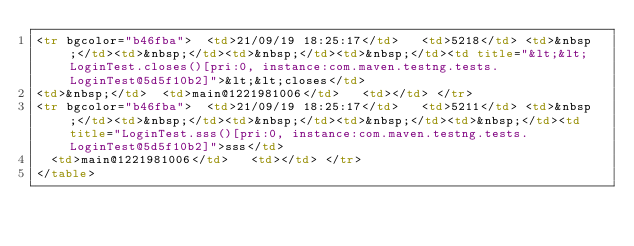Convert code to text. <code><loc_0><loc_0><loc_500><loc_500><_HTML_><tr bgcolor="b46fba">  <td>21/09/19 18:25:17</td>   <td>5218</td> <td>&nbsp;</td><td>&nbsp;</td><td>&nbsp;</td><td>&nbsp;</td><td title="&lt;&lt;LoginTest.closes()[pri:0, instance:com.maven.testng.tests.LoginTest@5d5f10b2]">&lt;&lt;closes</td> 
<td>&nbsp;</td>  <td>main@1221981006</td>   <td></td> </tr>
<tr bgcolor="b46fba">  <td>21/09/19 18:25:17</td>   <td>5211</td> <td>&nbsp;</td><td>&nbsp;</td><td>&nbsp;</td><td>&nbsp;</td><td>&nbsp;</td><td title="LoginTest.sss()[pri:0, instance:com.maven.testng.tests.LoginTest@5d5f10b2]">sss</td> 
  <td>main@1221981006</td>   <td></td> </tr>
</table>
</code> 